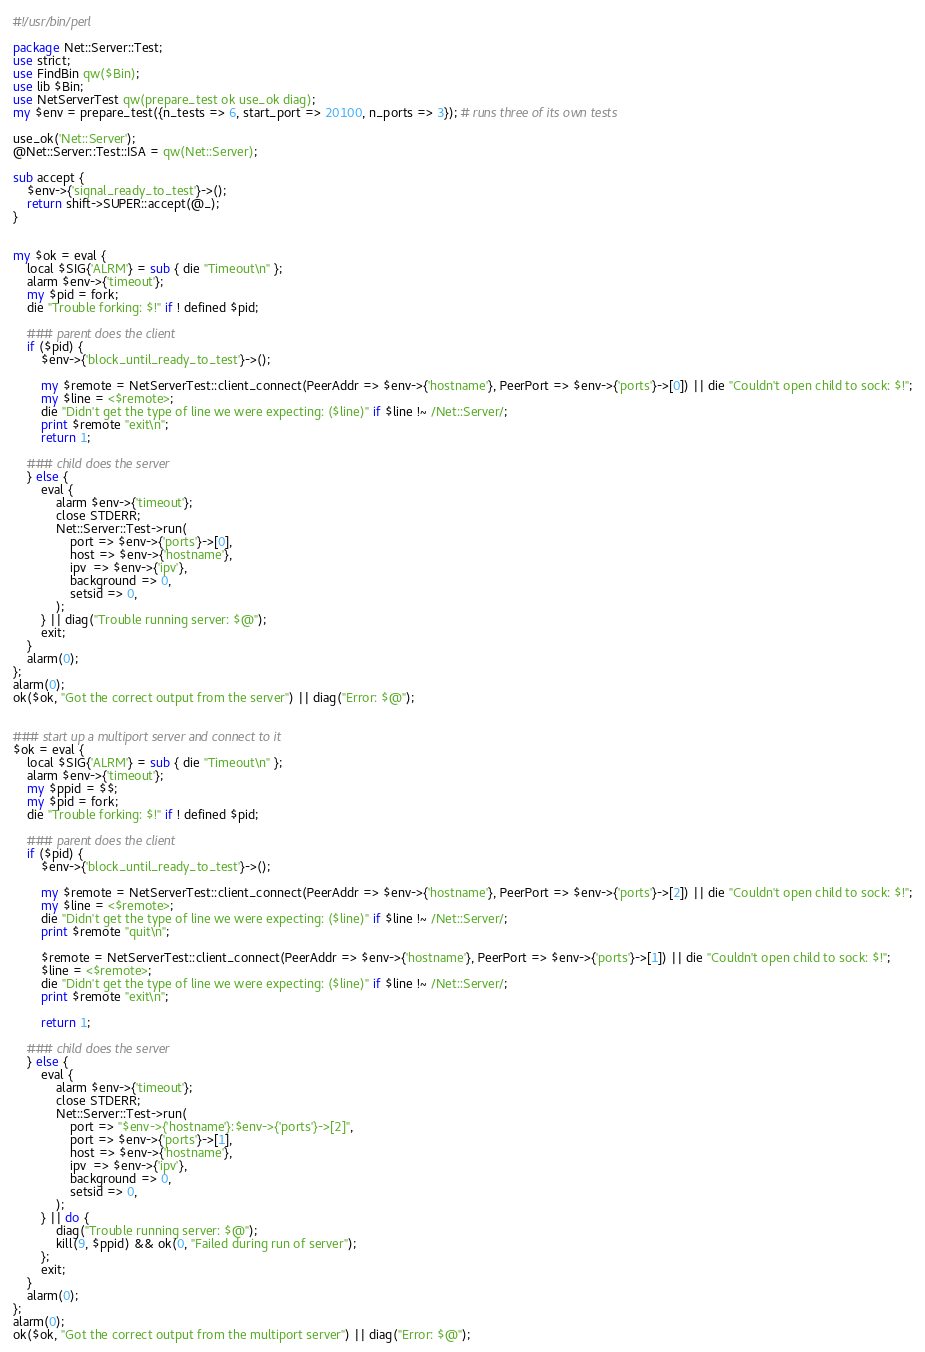Convert code to text. <code><loc_0><loc_0><loc_500><loc_500><_Perl_>#!/usr/bin/perl

package Net::Server::Test;
use strict;
use FindBin qw($Bin);
use lib $Bin;
use NetServerTest qw(prepare_test ok use_ok diag);
my $env = prepare_test({n_tests => 6, start_port => 20100, n_ports => 3}); # runs three of its own tests

use_ok('Net::Server');
@Net::Server::Test::ISA = qw(Net::Server);

sub accept {
    $env->{'signal_ready_to_test'}->();
    return shift->SUPER::accept(@_);
}


my $ok = eval {
    local $SIG{'ALRM'} = sub { die "Timeout\n" };
    alarm $env->{'timeout'};
    my $pid = fork;
    die "Trouble forking: $!" if ! defined $pid;

    ### parent does the client
    if ($pid) {
        $env->{'block_until_ready_to_test'}->();

        my $remote = NetServerTest::client_connect(PeerAddr => $env->{'hostname'}, PeerPort => $env->{'ports'}->[0]) || die "Couldn't open child to sock: $!";
        my $line = <$remote>;
        die "Didn't get the type of line we were expecting: ($line)" if $line !~ /Net::Server/;
        print $remote "exit\n";
        return 1;

    ### child does the server
    } else {
        eval {
            alarm $env->{'timeout'};
            close STDERR;
            Net::Server::Test->run(
                port => $env->{'ports'}->[0],
                host => $env->{'hostname'},
                ipv  => $env->{'ipv'},
                background => 0,
                setsid => 0,
            );
        } || diag("Trouble running server: $@");
        exit;
    }
    alarm(0);
};
alarm(0);
ok($ok, "Got the correct output from the server") || diag("Error: $@");


### start up a multiport server and connect to it
$ok = eval {
    local $SIG{'ALRM'} = sub { die "Timeout\n" };
    alarm $env->{'timeout'};
    my $ppid = $$;
    my $pid = fork;
    die "Trouble forking: $!" if ! defined $pid;

    ### parent does the client
    if ($pid) {
        $env->{'block_until_ready_to_test'}->();

        my $remote = NetServerTest::client_connect(PeerAddr => $env->{'hostname'}, PeerPort => $env->{'ports'}->[2]) || die "Couldn't open child to sock: $!";
        my $line = <$remote>;
        die "Didn't get the type of line we were expecting: ($line)" if $line !~ /Net::Server/;
        print $remote "quit\n";

        $remote = NetServerTest::client_connect(PeerAddr => $env->{'hostname'}, PeerPort => $env->{'ports'}->[1]) || die "Couldn't open child to sock: $!";
        $line = <$remote>;
        die "Didn't get the type of line we were expecting: ($line)" if $line !~ /Net::Server/;
        print $remote "exit\n";

        return 1;

    ### child does the server
    } else {
        eval {
            alarm $env->{'timeout'};
            close STDERR;
            Net::Server::Test->run(
                port => "$env->{'hostname'}:$env->{'ports'}->[2]",
                port => $env->{'ports'}->[1],
                host => $env->{'hostname'},
                ipv  => $env->{'ipv'},
                background => 0,
                setsid => 0,
            );
        } || do {
            diag("Trouble running server: $@");
            kill(9, $ppid) && ok(0, "Failed during run of server");
        };
        exit;
    }
    alarm(0);
};
alarm(0);
ok($ok, "Got the correct output from the multiport server") || diag("Error: $@");
</code> 